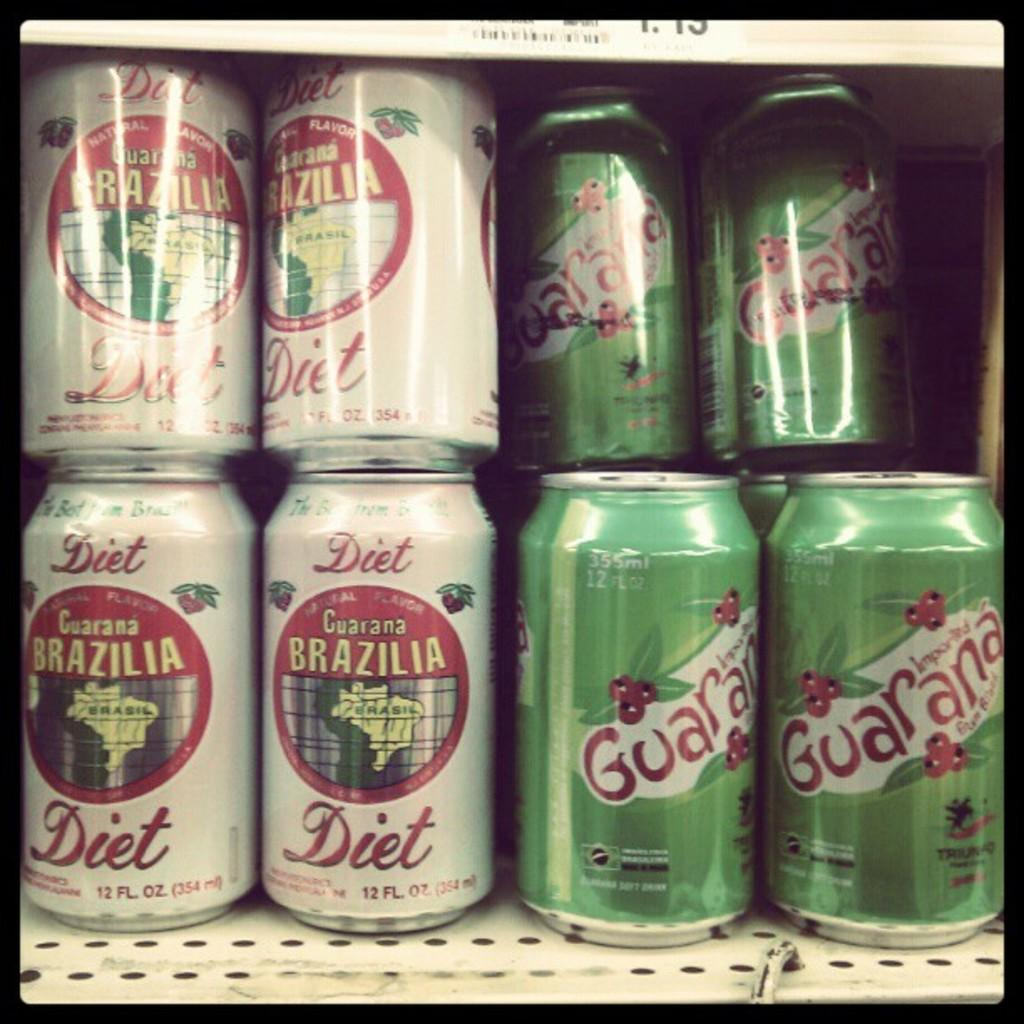<image>
Write a terse but informative summary of the picture. Cans of diet Brazilia are lined up next to other cans. 